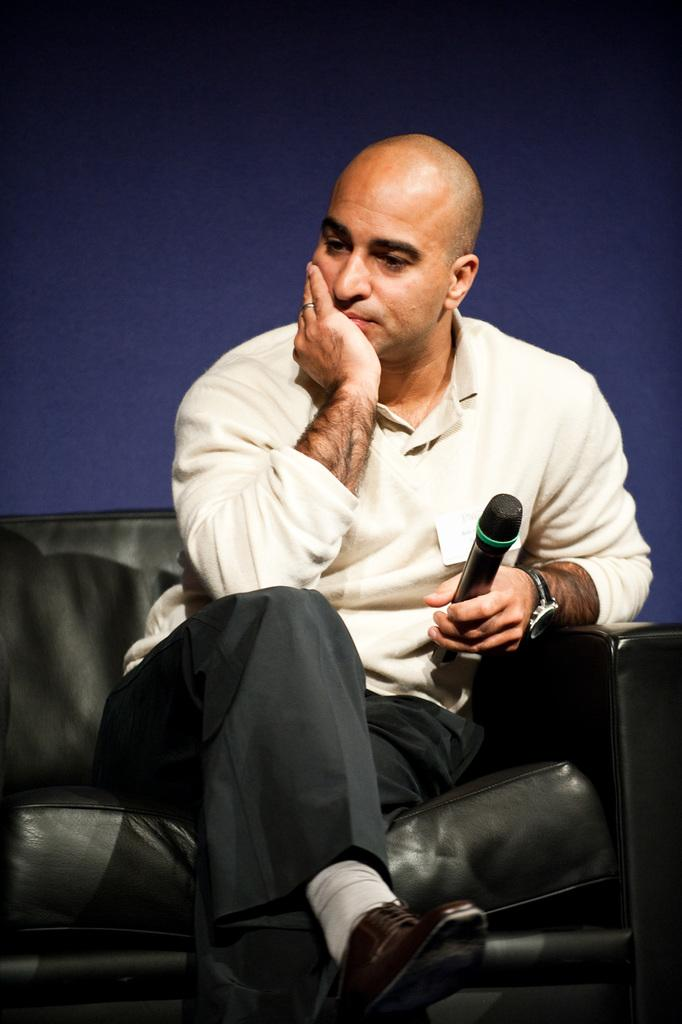Who is the main subject in the image? There is a man in the image. What is the man doing in the image? The man is sitting on a chair and holding a microphone. What can be seen behind the man in the image? There is a blue color background in the image. Can you tell me how deep the water is where the man is swimming in the image? There is no water or swimming depicted in the image; the man is sitting on a chair and holding a microphone. 